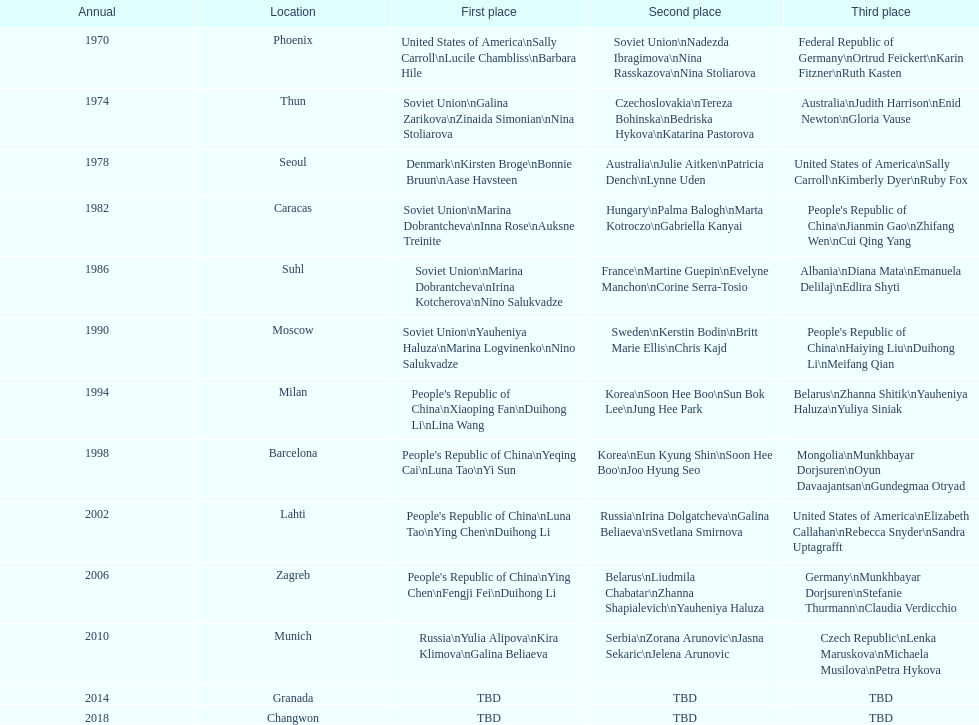Whose name is listed before bonnie bruun's in the gold column? Kirsten Broge. 